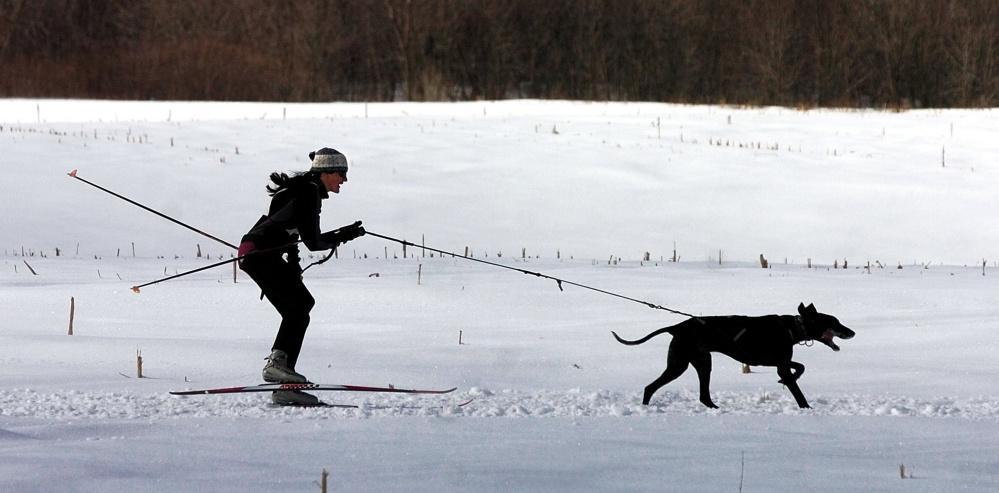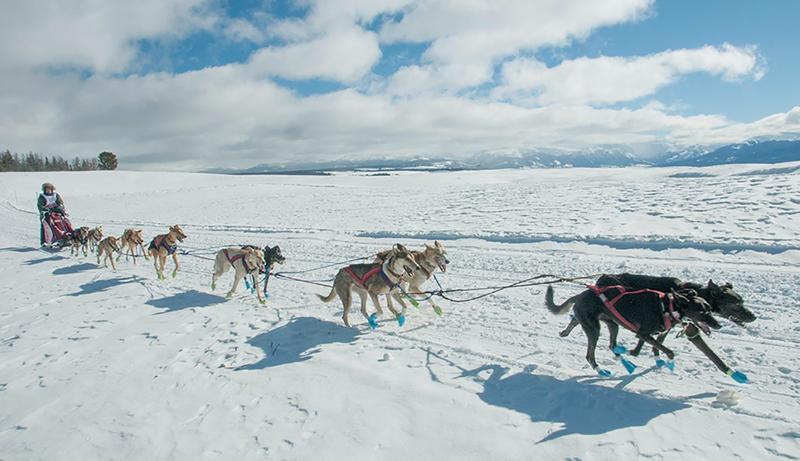The first image is the image on the left, the second image is the image on the right. Considering the images on both sides, is "One image shows no more than two harnessed dogs, which are moving across the snow." valid? Answer yes or no. Yes. The first image is the image on the left, the second image is the image on the right. Examine the images to the left and right. Is the description "Less than three dogs are visible in one of the images." accurate? Answer yes or no. Yes. 